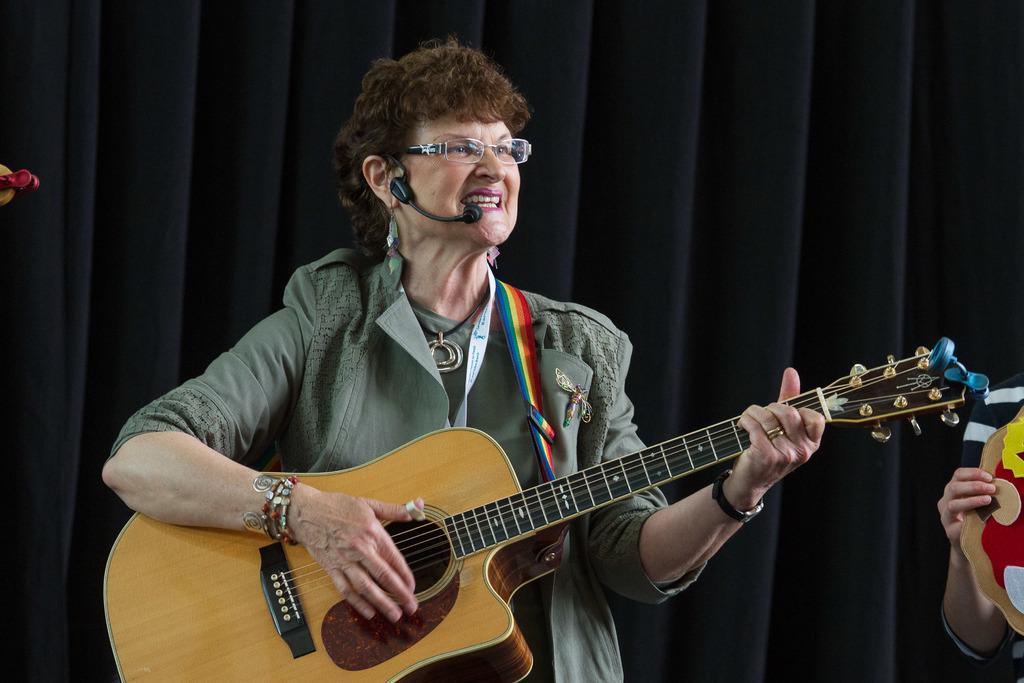How would you summarize this image in a sentence or two? In the middle, there is a woman standing and singing a song and playing a guitar. In the right bottom, there is another person holding an object which is half visible. In the background there is a curtain of blue in color. This image is taken inside the stage. 